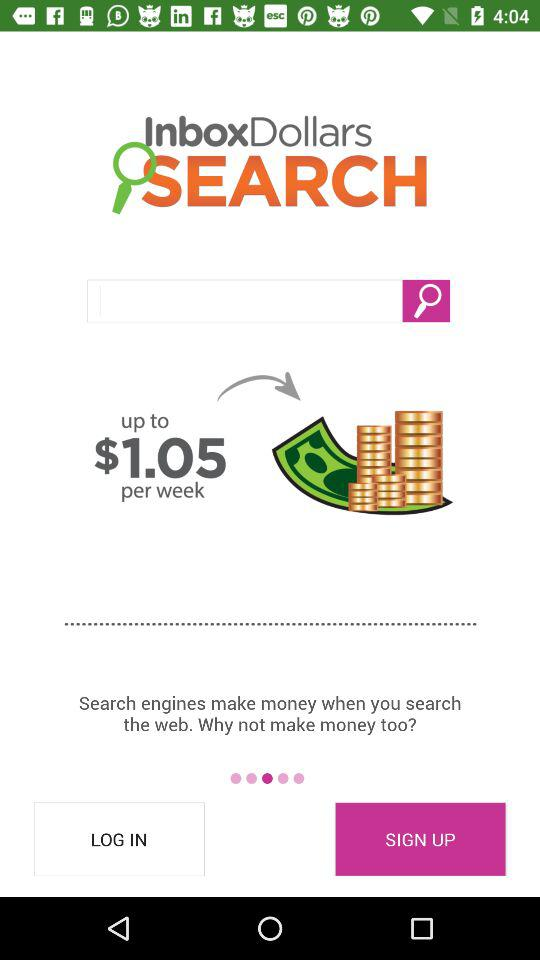What is the per-week amount? The per-week amount is $1.05. 